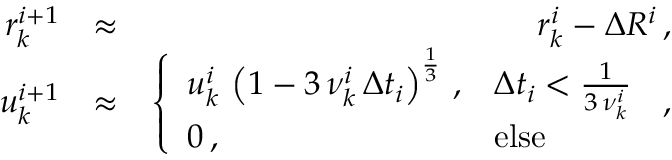<formula> <loc_0><loc_0><loc_500><loc_500>\begin{array} { r l r } { r _ { k } ^ { i + 1 } } & { \approx } & { r _ { k } ^ { i } - \Delta R ^ { i } \, , } \\ { u _ { k } ^ { i + 1 } } & { \approx } & { \left \{ \begin{array} { l l } { u _ { k } ^ { i } \, \left ( 1 - 3 \, \nu _ { k } ^ { i } \, \Delta t _ { i } \right ) ^ { \frac { 1 } { 3 } } \, , } & { \Delta t _ { i } < \frac { 1 } { 3 \, \nu _ { k } ^ { i } } } \\ { 0 \, , } & { e l s e } \end{array} \, , } \end{array}</formula> 